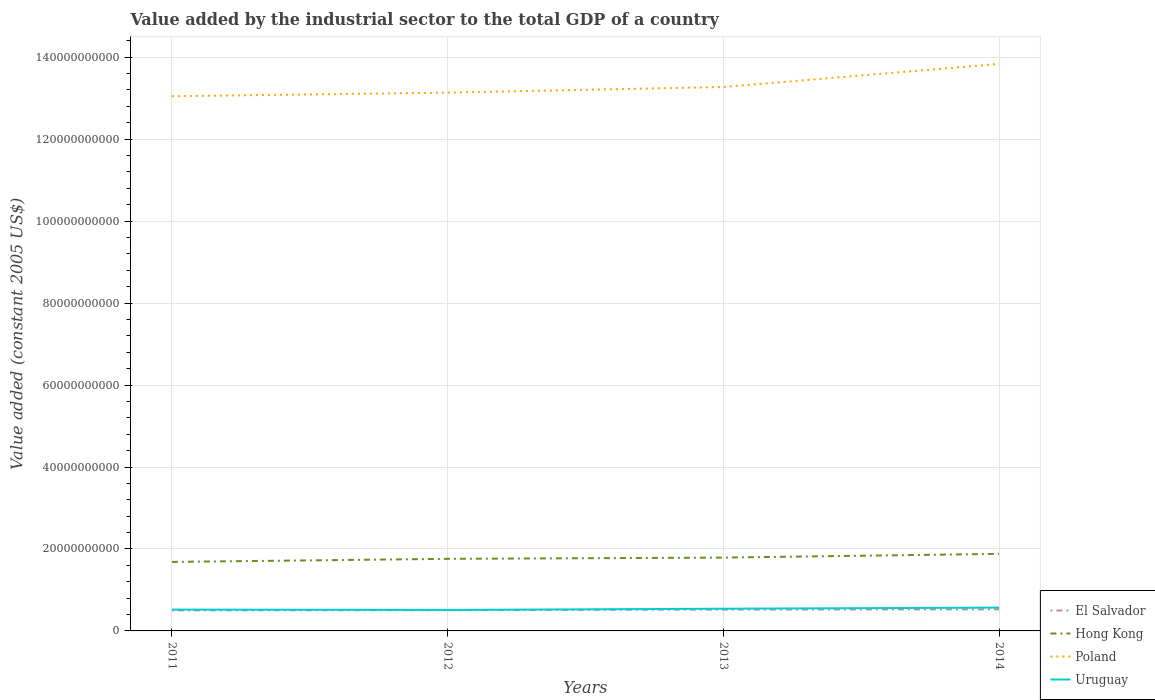Is the number of lines equal to the number of legend labels?
Make the answer very short. Yes. Across all years, what is the maximum value added by the industrial sector in El Salvador?
Keep it short and to the point. 5.02e+09. What is the total value added by the industrial sector in Hong Kong in the graph?
Give a very brief answer. -7.55e+08. What is the difference between the highest and the second highest value added by the industrial sector in Hong Kong?
Ensure brevity in your answer.  1.97e+09. What is the difference between the highest and the lowest value added by the industrial sector in Poland?
Keep it short and to the point. 1. What is the difference between two consecutive major ticks on the Y-axis?
Keep it short and to the point. 2.00e+1. Are the values on the major ticks of Y-axis written in scientific E-notation?
Ensure brevity in your answer.  No. Does the graph contain any zero values?
Offer a very short reply. No. Where does the legend appear in the graph?
Make the answer very short. Bottom right. What is the title of the graph?
Your answer should be very brief. Value added by the industrial sector to the total GDP of a country. What is the label or title of the X-axis?
Your answer should be compact. Years. What is the label or title of the Y-axis?
Offer a very short reply. Value added (constant 2005 US$). What is the Value added (constant 2005 US$) of El Salvador in 2011?
Provide a short and direct response. 5.02e+09. What is the Value added (constant 2005 US$) in Hong Kong in 2011?
Make the answer very short. 1.68e+1. What is the Value added (constant 2005 US$) of Poland in 2011?
Offer a very short reply. 1.30e+11. What is the Value added (constant 2005 US$) of Uruguay in 2011?
Offer a very short reply. 5.20e+09. What is the Value added (constant 2005 US$) in El Salvador in 2012?
Provide a short and direct response. 5.08e+09. What is the Value added (constant 2005 US$) in Hong Kong in 2012?
Provide a short and direct response. 1.76e+1. What is the Value added (constant 2005 US$) of Poland in 2012?
Your answer should be very brief. 1.31e+11. What is the Value added (constant 2005 US$) of Uruguay in 2012?
Keep it short and to the point. 5.11e+09. What is the Value added (constant 2005 US$) of El Salvador in 2013?
Make the answer very short. 5.21e+09. What is the Value added (constant 2005 US$) of Hong Kong in 2013?
Your response must be concise. 1.79e+1. What is the Value added (constant 2005 US$) in Poland in 2013?
Keep it short and to the point. 1.33e+11. What is the Value added (constant 2005 US$) of Uruguay in 2013?
Provide a succinct answer. 5.42e+09. What is the Value added (constant 2005 US$) in El Salvador in 2014?
Your answer should be compact. 5.27e+09. What is the Value added (constant 2005 US$) in Hong Kong in 2014?
Ensure brevity in your answer.  1.88e+1. What is the Value added (constant 2005 US$) in Poland in 2014?
Give a very brief answer. 1.38e+11. What is the Value added (constant 2005 US$) in Uruguay in 2014?
Your answer should be very brief. 5.69e+09. Across all years, what is the maximum Value added (constant 2005 US$) of El Salvador?
Make the answer very short. 5.27e+09. Across all years, what is the maximum Value added (constant 2005 US$) of Hong Kong?
Keep it short and to the point. 1.88e+1. Across all years, what is the maximum Value added (constant 2005 US$) in Poland?
Offer a very short reply. 1.38e+11. Across all years, what is the maximum Value added (constant 2005 US$) in Uruguay?
Ensure brevity in your answer.  5.69e+09. Across all years, what is the minimum Value added (constant 2005 US$) of El Salvador?
Your response must be concise. 5.02e+09. Across all years, what is the minimum Value added (constant 2005 US$) of Hong Kong?
Your response must be concise. 1.68e+1. Across all years, what is the minimum Value added (constant 2005 US$) in Poland?
Ensure brevity in your answer.  1.30e+11. Across all years, what is the minimum Value added (constant 2005 US$) in Uruguay?
Your response must be concise. 5.11e+09. What is the total Value added (constant 2005 US$) in El Salvador in the graph?
Offer a very short reply. 2.06e+1. What is the total Value added (constant 2005 US$) in Hong Kong in the graph?
Keep it short and to the point. 7.11e+1. What is the total Value added (constant 2005 US$) of Poland in the graph?
Your answer should be compact. 5.33e+11. What is the total Value added (constant 2005 US$) in Uruguay in the graph?
Give a very brief answer. 2.14e+1. What is the difference between the Value added (constant 2005 US$) of El Salvador in 2011 and that in 2012?
Your answer should be compact. -5.86e+07. What is the difference between the Value added (constant 2005 US$) of Hong Kong in 2011 and that in 2012?
Your answer should be very brief. -7.55e+08. What is the difference between the Value added (constant 2005 US$) in Poland in 2011 and that in 2012?
Your response must be concise. -8.73e+08. What is the difference between the Value added (constant 2005 US$) of Uruguay in 2011 and that in 2012?
Make the answer very short. 9.23e+07. What is the difference between the Value added (constant 2005 US$) in El Salvador in 2011 and that in 2013?
Provide a succinct answer. -1.95e+08. What is the difference between the Value added (constant 2005 US$) in Hong Kong in 2011 and that in 2013?
Your answer should be compact. -1.06e+09. What is the difference between the Value added (constant 2005 US$) of Poland in 2011 and that in 2013?
Ensure brevity in your answer.  -2.25e+09. What is the difference between the Value added (constant 2005 US$) in Uruguay in 2011 and that in 2013?
Your answer should be compact. -2.12e+08. What is the difference between the Value added (constant 2005 US$) in El Salvador in 2011 and that in 2014?
Offer a terse response. -2.50e+08. What is the difference between the Value added (constant 2005 US$) of Hong Kong in 2011 and that in 2014?
Keep it short and to the point. -1.97e+09. What is the difference between the Value added (constant 2005 US$) in Poland in 2011 and that in 2014?
Your answer should be very brief. -7.88e+09. What is the difference between the Value added (constant 2005 US$) of Uruguay in 2011 and that in 2014?
Your answer should be compact. -4.84e+08. What is the difference between the Value added (constant 2005 US$) in El Salvador in 2012 and that in 2013?
Your answer should be compact. -1.36e+08. What is the difference between the Value added (constant 2005 US$) of Hong Kong in 2012 and that in 2013?
Provide a short and direct response. -3.00e+08. What is the difference between the Value added (constant 2005 US$) in Poland in 2012 and that in 2013?
Your response must be concise. -1.38e+09. What is the difference between the Value added (constant 2005 US$) in Uruguay in 2012 and that in 2013?
Your answer should be compact. -3.04e+08. What is the difference between the Value added (constant 2005 US$) of El Salvador in 2012 and that in 2014?
Ensure brevity in your answer.  -1.91e+08. What is the difference between the Value added (constant 2005 US$) in Hong Kong in 2012 and that in 2014?
Provide a short and direct response. -1.21e+09. What is the difference between the Value added (constant 2005 US$) in Poland in 2012 and that in 2014?
Your answer should be compact. -7.01e+09. What is the difference between the Value added (constant 2005 US$) of Uruguay in 2012 and that in 2014?
Offer a terse response. -5.76e+08. What is the difference between the Value added (constant 2005 US$) of El Salvador in 2013 and that in 2014?
Your answer should be very brief. -5.52e+07. What is the difference between the Value added (constant 2005 US$) in Hong Kong in 2013 and that in 2014?
Make the answer very short. -9.12e+08. What is the difference between the Value added (constant 2005 US$) in Poland in 2013 and that in 2014?
Ensure brevity in your answer.  -5.63e+09. What is the difference between the Value added (constant 2005 US$) of Uruguay in 2013 and that in 2014?
Your answer should be compact. -2.72e+08. What is the difference between the Value added (constant 2005 US$) in El Salvador in 2011 and the Value added (constant 2005 US$) in Hong Kong in 2012?
Your response must be concise. -1.26e+1. What is the difference between the Value added (constant 2005 US$) in El Salvador in 2011 and the Value added (constant 2005 US$) in Poland in 2012?
Make the answer very short. -1.26e+11. What is the difference between the Value added (constant 2005 US$) of El Salvador in 2011 and the Value added (constant 2005 US$) of Uruguay in 2012?
Provide a short and direct response. -9.42e+07. What is the difference between the Value added (constant 2005 US$) in Hong Kong in 2011 and the Value added (constant 2005 US$) in Poland in 2012?
Offer a very short reply. -1.15e+11. What is the difference between the Value added (constant 2005 US$) in Hong Kong in 2011 and the Value added (constant 2005 US$) in Uruguay in 2012?
Your answer should be very brief. 1.17e+1. What is the difference between the Value added (constant 2005 US$) of Poland in 2011 and the Value added (constant 2005 US$) of Uruguay in 2012?
Provide a succinct answer. 1.25e+11. What is the difference between the Value added (constant 2005 US$) in El Salvador in 2011 and the Value added (constant 2005 US$) in Hong Kong in 2013?
Provide a succinct answer. -1.29e+1. What is the difference between the Value added (constant 2005 US$) in El Salvador in 2011 and the Value added (constant 2005 US$) in Poland in 2013?
Offer a terse response. -1.28e+11. What is the difference between the Value added (constant 2005 US$) in El Salvador in 2011 and the Value added (constant 2005 US$) in Uruguay in 2013?
Your answer should be compact. -3.98e+08. What is the difference between the Value added (constant 2005 US$) of Hong Kong in 2011 and the Value added (constant 2005 US$) of Poland in 2013?
Provide a succinct answer. -1.16e+11. What is the difference between the Value added (constant 2005 US$) of Hong Kong in 2011 and the Value added (constant 2005 US$) of Uruguay in 2013?
Your answer should be very brief. 1.14e+1. What is the difference between the Value added (constant 2005 US$) of Poland in 2011 and the Value added (constant 2005 US$) of Uruguay in 2013?
Make the answer very short. 1.25e+11. What is the difference between the Value added (constant 2005 US$) of El Salvador in 2011 and the Value added (constant 2005 US$) of Hong Kong in 2014?
Make the answer very short. -1.38e+1. What is the difference between the Value added (constant 2005 US$) of El Salvador in 2011 and the Value added (constant 2005 US$) of Poland in 2014?
Give a very brief answer. -1.33e+11. What is the difference between the Value added (constant 2005 US$) in El Salvador in 2011 and the Value added (constant 2005 US$) in Uruguay in 2014?
Keep it short and to the point. -6.70e+08. What is the difference between the Value added (constant 2005 US$) of Hong Kong in 2011 and the Value added (constant 2005 US$) of Poland in 2014?
Provide a succinct answer. -1.22e+11. What is the difference between the Value added (constant 2005 US$) of Hong Kong in 2011 and the Value added (constant 2005 US$) of Uruguay in 2014?
Your answer should be very brief. 1.11e+1. What is the difference between the Value added (constant 2005 US$) in Poland in 2011 and the Value added (constant 2005 US$) in Uruguay in 2014?
Make the answer very short. 1.25e+11. What is the difference between the Value added (constant 2005 US$) in El Salvador in 2012 and the Value added (constant 2005 US$) in Hong Kong in 2013?
Provide a short and direct response. -1.28e+1. What is the difference between the Value added (constant 2005 US$) of El Salvador in 2012 and the Value added (constant 2005 US$) of Poland in 2013?
Ensure brevity in your answer.  -1.28e+11. What is the difference between the Value added (constant 2005 US$) of El Salvador in 2012 and the Value added (constant 2005 US$) of Uruguay in 2013?
Keep it short and to the point. -3.40e+08. What is the difference between the Value added (constant 2005 US$) in Hong Kong in 2012 and the Value added (constant 2005 US$) in Poland in 2013?
Provide a short and direct response. -1.15e+11. What is the difference between the Value added (constant 2005 US$) of Hong Kong in 2012 and the Value added (constant 2005 US$) of Uruguay in 2013?
Ensure brevity in your answer.  1.22e+1. What is the difference between the Value added (constant 2005 US$) of Poland in 2012 and the Value added (constant 2005 US$) of Uruguay in 2013?
Your answer should be compact. 1.26e+11. What is the difference between the Value added (constant 2005 US$) of El Salvador in 2012 and the Value added (constant 2005 US$) of Hong Kong in 2014?
Keep it short and to the point. -1.37e+1. What is the difference between the Value added (constant 2005 US$) in El Salvador in 2012 and the Value added (constant 2005 US$) in Poland in 2014?
Your answer should be compact. -1.33e+11. What is the difference between the Value added (constant 2005 US$) in El Salvador in 2012 and the Value added (constant 2005 US$) in Uruguay in 2014?
Provide a short and direct response. -6.12e+08. What is the difference between the Value added (constant 2005 US$) of Hong Kong in 2012 and the Value added (constant 2005 US$) of Poland in 2014?
Make the answer very short. -1.21e+11. What is the difference between the Value added (constant 2005 US$) of Hong Kong in 2012 and the Value added (constant 2005 US$) of Uruguay in 2014?
Offer a very short reply. 1.19e+1. What is the difference between the Value added (constant 2005 US$) in Poland in 2012 and the Value added (constant 2005 US$) in Uruguay in 2014?
Your answer should be compact. 1.26e+11. What is the difference between the Value added (constant 2005 US$) in El Salvador in 2013 and the Value added (constant 2005 US$) in Hong Kong in 2014?
Make the answer very short. -1.36e+1. What is the difference between the Value added (constant 2005 US$) in El Salvador in 2013 and the Value added (constant 2005 US$) in Poland in 2014?
Your response must be concise. -1.33e+11. What is the difference between the Value added (constant 2005 US$) in El Salvador in 2013 and the Value added (constant 2005 US$) in Uruguay in 2014?
Make the answer very short. -4.75e+08. What is the difference between the Value added (constant 2005 US$) in Hong Kong in 2013 and the Value added (constant 2005 US$) in Poland in 2014?
Your answer should be compact. -1.20e+11. What is the difference between the Value added (constant 2005 US$) in Hong Kong in 2013 and the Value added (constant 2005 US$) in Uruguay in 2014?
Offer a very short reply. 1.22e+1. What is the difference between the Value added (constant 2005 US$) in Poland in 2013 and the Value added (constant 2005 US$) in Uruguay in 2014?
Your answer should be compact. 1.27e+11. What is the average Value added (constant 2005 US$) in El Salvador per year?
Make the answer very short. 5.14e+09. What is the average Value added (constant 2005 US$) in Hong Kong per year?
Ensure brevity in your answer.  1.78e+1. What is the average Value added (constant 2005 US$) of Poland per year?
Your response must be concise. 1.33e+11. What is the average Value added (constant 2005 US$) of Uruguay per year?
Your answer should be very brief. 5.36e+09. In the year 2011, what is the difference between the Value added (constant 2005 US$) in El Salvador and Value added (constant 2005 US$) in Hong Kong?
Provide a succinct answer. -1.18e+1. In the year 2011, what is the difference between the Value added (constant 2005 US$) of El Salvador and Value added (constant 2005 US$) of Poland?
Your response must be concise. -1.25e+11. In the year 2011, what is the difference between the Value added (constant 2005 US$) of El Salvador and Value added (constant 2005 US$) of Uruguay?
Your answer should be compact. -1.87e+08. In the year 2011, what is the difference between the Value added (constant 2005 US$) in Hong Kong and Value added (constant 2005 US$) in Poland?
Your response must be concise. -1.14e+11. In the year 2011, what is the difference between the Value added (constant 2005 US$) in Hong Kong and Value added (constant 2005 US$) in Uruguay?
Provide a short and direct response. 1.16e+1. In the year 2011, what is the difference between the Value added (constant 2005 US$) in Poland and Value added (constant 2005 US$) in Uruguay?
Provide a succinct answer. 1.25e+11. In the year 2012, what is the difference between the Value added (constant 2005 US$) of El Salvador and Value added (constant 2005 US$) of Hong Kong?
Provide a short and direct response. -1.25e+1. In the year 2012, what is the difference between the Value added (constant 2005 US$) of El Salvador and Value added (constant 2005 US$) of Poland?
Keep it short and to the point. -1.26e+11. In the year 2012, what is the difference between the Value added (constant 2005 US$) in El Salvador and Value added (constant 2005 US$) in Uruguay?
Give a very brief answer. -3.57e+07. In the year 2012, what is the difference between the Value added (constant 2005 US$) of Hong Kong and Value added (constant 2005 US$) of Poland?
Offer a very short reply. -1.14e+11. In the year 2012, what is the difference between the Value added (constant 2005 US$) in Hong Kong and Value added (constant 2005 US$) in Uruguay?
Keep it short and to the point. 1.25e+1. In the year 2012, what is the difference between the Value added (constant 2005 US$) in Poland and Value added (constant 2005 US$) in Uruguay?
Make the answer very short. 1.26e+11. In the year 2013, what is the difference between the Value added (constant 2005 US$) of El Salvador and Value added (constant 2005 US$) of Hong Kong?
Provide a succinct answer. -1.27e+1. In the year 2013, what is the difference between the Value added (constant 2005 US$) of El Salvador and Value added (constant 2005 US$) of Poland?
Offer a very short reply. -1.28e+11. In the year 2013, what is the difference between the Value added (constant 2005 US$) of El Salvador and Value added (constant 2005 US$) of Uruguay?
Your answer should be very brief. -2.03e+08. In the year 2013, what is the difference between the Value added (constant 2005 US$) of Hong Kong and Value added (constant 2005 US$) of Poland?
Offer a terse response. -1.15e+11. In the year 2013, what is the difference between the Value added (constant 2005 US$) in Hong Kong and Value added (constant 2005 US$) in Uruguay?
Keep it short and to the point. 1.25e+1. In the year 2013, what is the difference between the Value added (constant 2005 US$) of Poland and Value added (constant 2005 US$) of Uruguay?
Your response must be concise. 1.27e+11. In the year 2014, what is the difference between the Value added (constant 2005 US$) in El Salvador and Value added (constant 2005 US$) in Hong Kong?
Your answer should be very brief. -1.35e+1. In the year 2014, what is the difference between the Value added (constant 2005 US$) of El Salvador and Value added (constant 2005 US$) of Poland?
Your answer should be compact. -1.33e+11. In the year 2014, what is the difference between the Value added (constant 2005 US$) of El Salvador and Value added (constant 2005 US$) of Uruguay?
Offer a terse response. -4.20e+08. In the year 2014, what is the difference between the Value added (constant 2005 US$) in Hong Kong and Value added (constant 2005 US$) in Poland?
Make the answer very short. -1.20e+11. In the year 2014, what is the difference between the Value added (constant 2005 US$) in Hong Kong and Value added (constant 2005 US$) in Uruguay?
Your response must be concise. 1.31e+1. In the year 2014, what is the difference between the Value added (constant 2005 US$) in Poland and Value added (constant 2005 US$) in Uruguay?
Offer a very short reply. 1.33e+11. What is the ratio of the Value added (constant 2005 US$) of Hong Kong in 2011 to that in 2012?
Offer a terse response. 0.96. What is the ratio of the Value added (constant 2005 US$) in Poland in 2011 to that in 2012?
Offer a very short reply. 0.99. What is the ratio of the Value added (constant 2005 US$) of Uruguay in 2011 to that in 2012?
Give a very brief answer. 1.02. What is the ratio of the Value added (constant 2005 US$) of El Salvador in 2011 to that in 2013?
Your response must be concise. 0.96. What is the ratio of the Value added (constant 2005 US$) of Hong Kong in 2011 to that in 2013?
Offer a terse response. 0.94. What is the ratio of the Value added (constant 2005 US$) of Poland in 2011 to that in 2013?
Your response must be concise. 0.98. What is the ratio of the Value added (constant 2005 US$) of Uruguay in 2011 to that in 2013?
Provide a short and direct response. 0.96. What is the ratio of the Value added (constant 2005 US$) of El Salvador in 2011 to that in 2014?
Make the answer very short. 0.95. What is the ratio of the Value added (constant 2005 US$) in Hong Kong in 2011 to that in 2014?
Give a very brief answer. 0.9. What is the ratio of the Value added (constant 2005 US$) in Poland in 2011 to that in 2014?
Provide a succinct answer. 0.94. What is the ratio of the Value added (constant 2005 US$) of Uruguay in 2011 to that in 2014?
Provide a short and direct response. 0.92. What is the ratio of the Value added (constant 2005 US$) of El Salvador in 2012 to that in 2013?
Provide a succinct answer. 0.97. What is the ratio of the Value added (constant 2005 US$) in Hong Kong in 2012 to that in 2013?
Your response must be concise. 0.98. What is the ratio of the Value added (constant 2005 US$) in Poland in 2012 to that in 2013?
Provide a short and direct response. 0.99. What is the ratio of the Value added (constant 2005 US$) of Uruguay in 2012 to that in 2013?
Provide a succinct answer. 0.94. What is the ratio of the Value added (constant 2005 US$) of El Salvador in 2012 to that in 2014?
Your response must be concise. 0.96. What is the ratio of the Value added (constant 2005 US$) in Hong Kong in 2012 to that in 2014?
Your answer should be compact. 0.94. What is the ratio of the Value added (constant 2005 US$) of Poland in 2012 to that in 2014?
Keep it short and to the point. 0.95. What is the ratio of the Value added (constant 2005 US$) of Uruguay in 2012 to that in 2014?
Ensure brevity in your answer.  0.9. What is the ratio of the Value added (constant 2005 US$) in El Salvador in 2013 to that in 2014?
Your answer should be very brief. 0.99. What is the ratio of the Value added (constant 2005 US$) in Hong Kong in 2013 to that in 2014?
Provide a short and direct response. 0.95. What is the ratio of the Value added (constant 2005 US$) in Poland in 2013 to that in 2014?
Provide a short and direct response. 0.96. What is the ratio of the Value added (constant 2005 US$) in Uruguay in 2013 to that in 2014?
Ensure brevity in your answer.  0.95. What is the difference between the highest and the second highest Value added (constant 2005 US$) of El Salvador?
Offer a very short reply. 5.52e+07. What is the difference between the highest and the second highest Value added (constant 2005 US$) in Hong Kong?
Give a very brief answer. 9.12e+08. What is the difference between the highest and the second highest Value added (constant 2005 US$) of Poland?
Keep it short and to the point. 5.63e+09. What is the difference between the highest and the second highest Value added (constant 2005 US$) in Uruguay?
Make the answer very short. 2.72e+08. What is the difference between the highest and the lowest Value added (constant 2005 US$) of El Salvador?
Ensure brevity in your answer.  2.50e+08. What is the difference between the highest and the lowest Value added (constant 2005 US$) in Hong Kong?
Provide a succinct answer. 1.97e+09. What is the difference between the highest and the lowest Value added (constant 2005 US$) in Poland?
Provide a short and direct response. 7.88e+09. What is the difference between the highest and the lowest Value added (constant 2005 US$) of Uruguay?
Your response must be concise. 5.76e+08. 